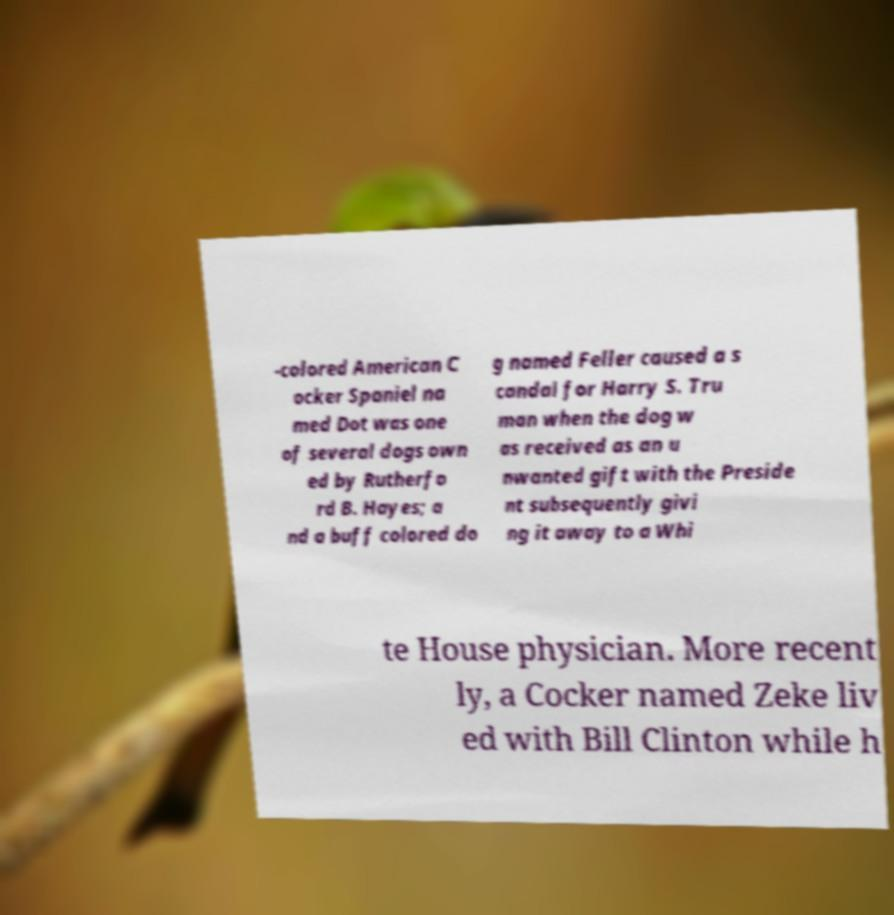There's text embedded in this image that I need extracted. Can you transcribe it verbatim? -colored American C ocker Spaniel na med Dot was one of several dogs own ed by Rutherfo rd B. Hayes; a nd a buff colored do g named Feller caused a s candal for Harry S. Tru man when the dog w as received as an u nwanted gift with the Preside nt subsequently givi ng it away to a Whi te House physician. More recent ly, a Cocker named Zeke liv ed with Bill Clinton while h 